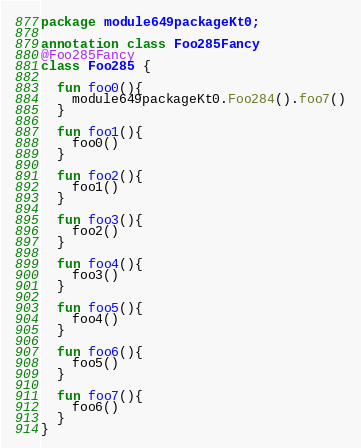<code> <loc_0><loc_0><loc_500><loc_500><_Kotlin_>package module649packageKt0;

annotation class Foo285Fancy
@Foo285Fancy
class Foo285 {

  fun foo0(){
    module649packageKt0.Foo284().foo7()
  }

  fun foo1(){
    foo0()
  }

  fun foo2(){
    foo1()
  }

  fun foo3(){
    foo2()
  }

  fun foo4(){
    foo3()
  }

  fun foo5(){
    foo4()
  }

  fun foo6(){
    foo5()
  }

  fun foo7(){
    foo6()
  }
}</code> 